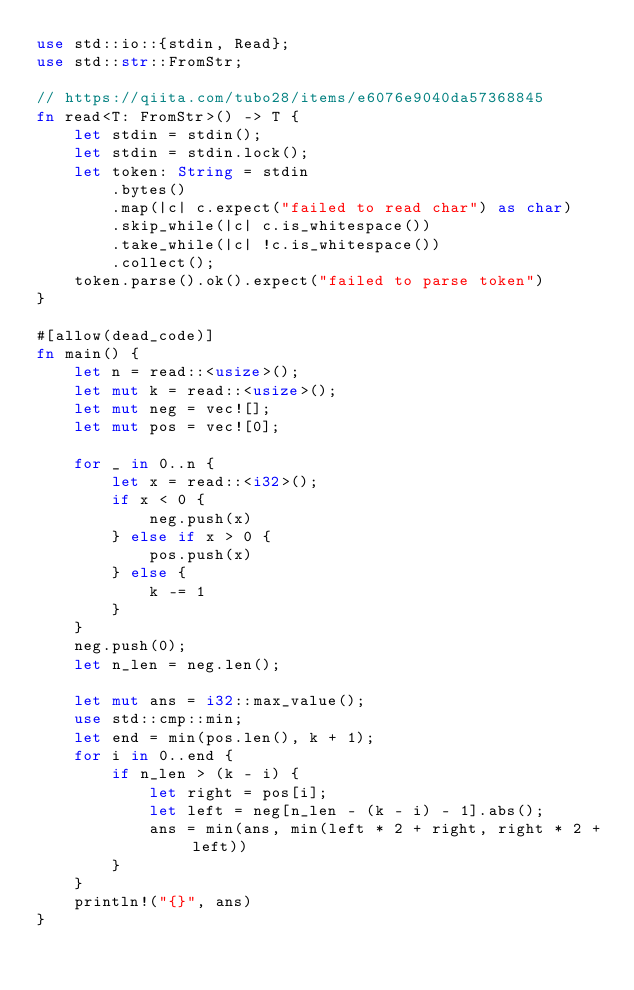<code> <loc_0><loc_0><loc_500><loc_500><_Rust_>use std::io::{stdin, Read};
use std::str::FromStr;

// https://qiita.com/tubo28/items/e6076e9040da57368845
fn read<T: FromStr>() -> T {
    let stdin = stdin();
    let stdin = stdin.lock();
    let token: String = stdin
        .bytes()
        .map(|c| c.expect("failed to read char") as char)
        .skip_while(|c| c.is_whitespace())
        .take_while(|c| !c.is_whitespace())
        .collect();
    token.parse().ok().expect("failed to parse token")
}

#[allow(dead_code)]
fn main() {
    let n = read::<usize>();
    let mut k = read::<usize>();
    let mut neg = vec![];
    let mut pos = vec![0];

    for _ in 0..n {
        let x = read::<i32>();
        if x < 0 {
            neg.push(x)
        } else if x > 0 {
            pos.push(x)
        } else {
            k -= 1
        }
    }
    neg.push(0);
    let n_len = neg.len();

    let mut ans = i32::max_value();
    use std::cmp::min;
    let end = min(pos.len(), k + 1);
    for i in 0..end {
        if n_len > (k - i) {
            let right = pos[i];
            let left = neg[n_len - (k - i) - 1].abs();
            ans = min(ans, min(left * 2 + right, right * 2 + left))
        }
    }
    println!("{}", ans)
}
</code> 